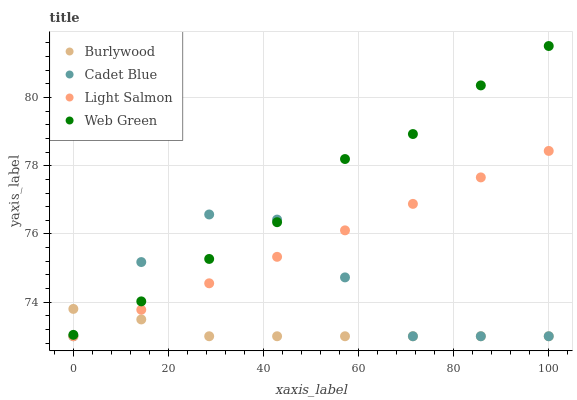Does Burlywood have the minimum area under the curve?
Answer yes or no. Yes. Does Web Green have the maximum area under the curve?
Answer yes or no. Yes. Does Light Salmon have the minimum area under the curve?
Answer yes or no. No. Does Light Salmon have the maximum area under the curve?
Answer yes or no. No. Is Light Salmon the smoothest?
Answer yes or no. Yes. Is Cadet Blue the roughest?
Answer yes or no. Yes. Is Cadet Blue the smoothest?
Answer yes or no. No. Is Light Salmon the roughest?
Answer yes or no. No. Does Burlywood have the lowest value?
Answer yes or no. Yes. Does Web Green have the lowest value?
Answer yes or no. No. Does Web Green have the highest value?
Answer yes or no. Yes. Does Light Salmon have the highest value?
Answer yes or no. No. Is Light Salmon less than Web Green?
Answer yes or no. Yes. Is Web Green greater than Light Salmon?
Answer yes or no. Yes. Does Burlywood intersect Light Salmon?
Answer yes or no. Yes. Is Burlywood less than Light Salmon?
Answer yes or no. No. Is Burlywood greater than Light Salmon?
Answer yes or no. No. Does Light Salmon intersect Web Green?
Answer yes or no. No. 